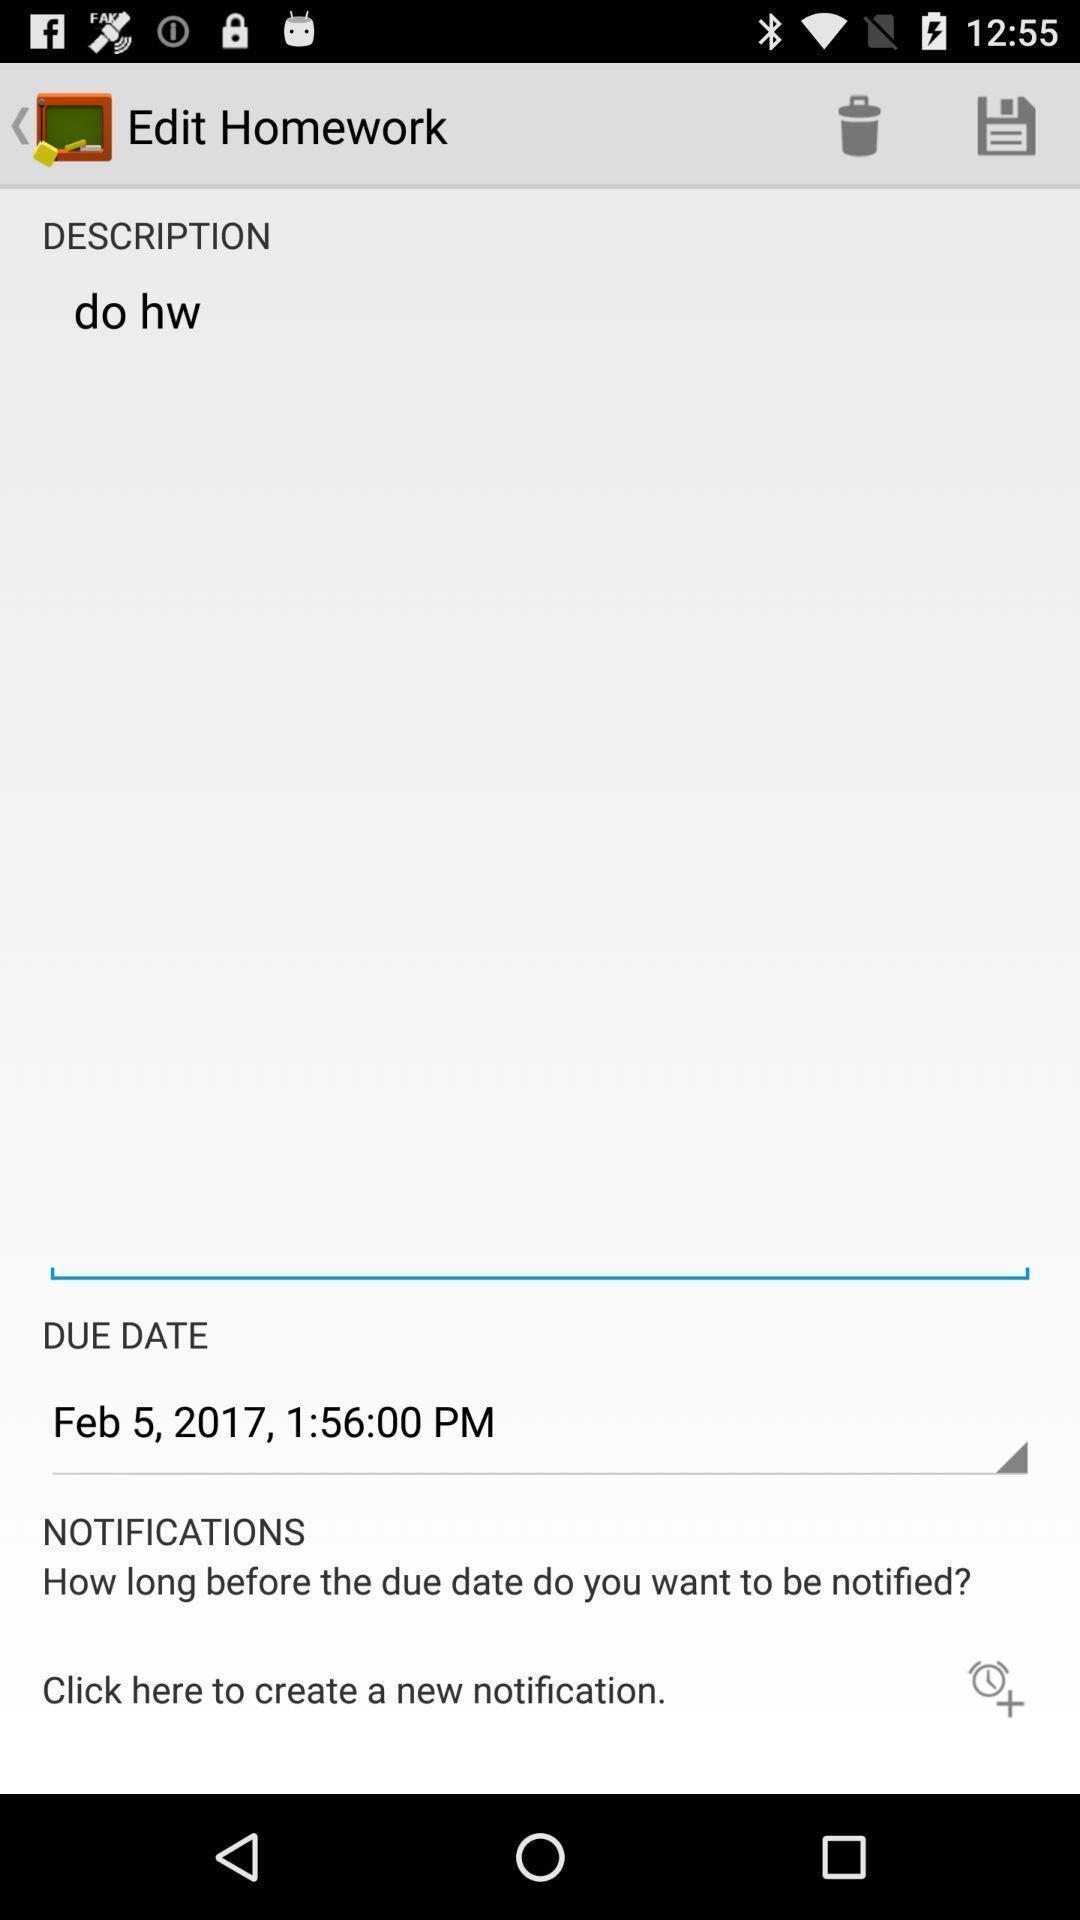Provide a detailed account of this screenshot. Text box is displaying to add notification reminders. 